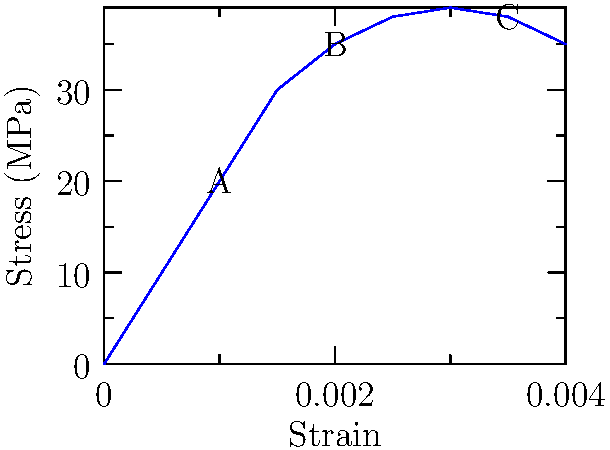As a Dogri literature advocate and database curator, you're tasked with analyzing a stress-strain curve for a concrete sample to ensure the structural integrity of a library housing rare Dogri manuscripts. Identify the elastic limit (yield point) of the concrete sample from the given stress-strain curve. To identify the elastic limit (yield point) of the concrete sample, we need to analyze the stress-strain curve:

1. The elastic limit is the point where the stress-strain relationship ceases to be linear and the material begins to deform plastically.

2. Examine the curve from left to right:
   a. Initially, the curve is approximately linear from the origin to point A.
   b. After point A, the curve begins to deviate from linearity.

3. The elastic limit is typically at the end of the linear portion, just before the curve starts to bend significantly.

4. In this case, point A (0.001, 20) represents the approximate elastic limit.

5. Beyond point A:
   - The curve becomes non-linear up to point B (0.002, 35).
   - It then continues to point C (0.0035, 38), which appears to be the ultimate strength.
   - After point C, the stress decreases, indicating failure.

6. The elastic limit (yield point) is crucial for ensuring the structural integrity of the library, as it represents the maximum stress the concrete can withstand without permanent deformation.
Answer: Point A (strain ≈ 0.001, stress ≈ 20 MPa) 